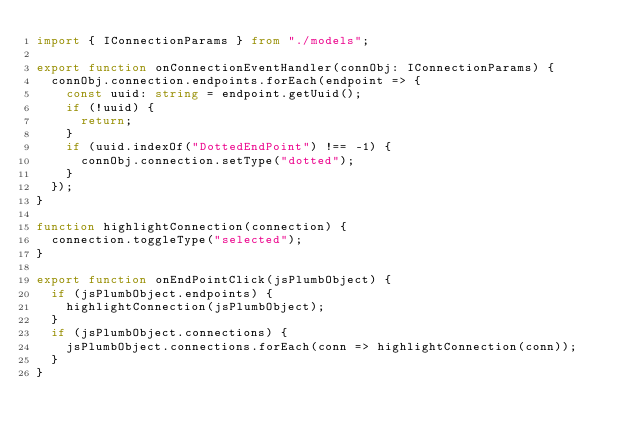<code> <loc_0><loc_0><loc_500><loc_500><_TypeScript_>import { IConnectionParams } from "./models";

export function onConnectionEventHandler(connObj: IConnectionParams) {
  connObj.connection.endpoints.forEach(endpoint => {
    const uuid: string = endpoint.getUuid();
    if (!uuid) {
      return;
    }
    if (uuid.indexOf("DottedEndPoint") !== -1) {
      connObj.connection.setType("dotted");
    }
  });
}

function highlightConnection(connection) {
  connection.toggleType("selected");
}

export function onEndPointClick(jsPlumbObject) {
  if (jsPlumbObject.endpoints) {
    highlightConnection(jsPlumbObject);
  }
  if (jsPlumbObject.connections) {
    jsPlumbObject.connections.forEach(conn => highlightConnection(conn));
  }
}
</code> 